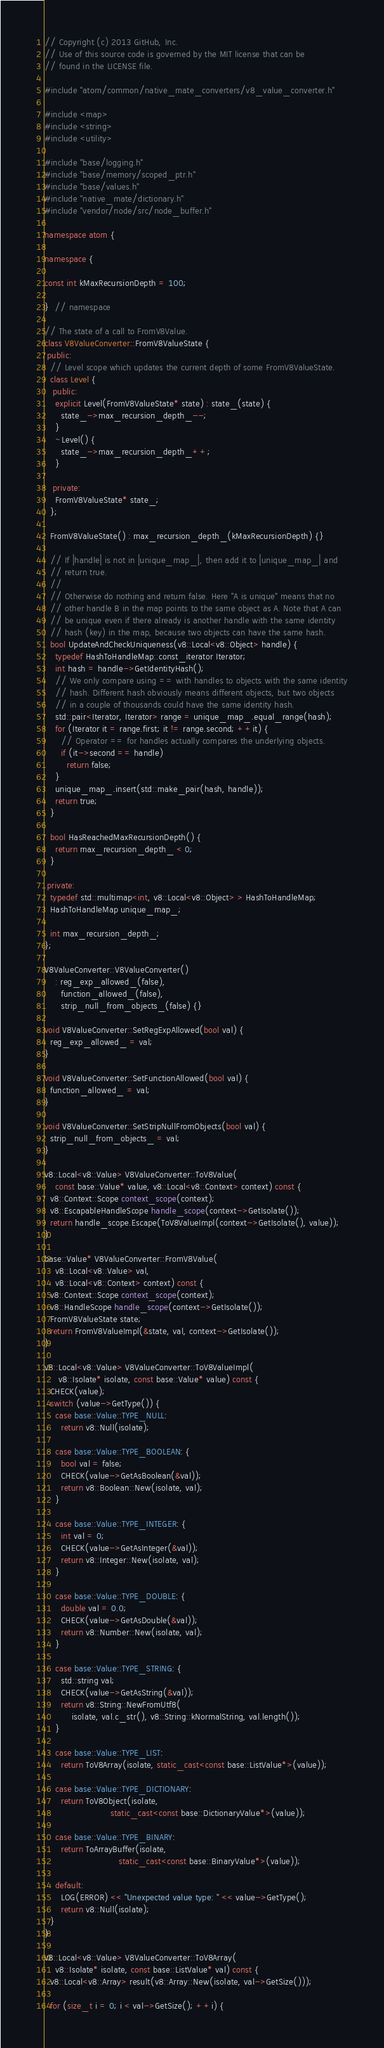<code> <loc_0><loc_0><loc_500><loc_500><_C++_>// Copyright (c) 2013 GitHub, Inc.
// Use of this source code is governed by the MIT license that can be
// found in the LICENSE file.

#include "atom/common/native_mate_converters/v8_value_converter.h"

#include <map>
#include <string>
#include <utility>

#include "base/logging.h"
#include "base/memory/scoped_ptr.h"
#include "base/values.h"
#include "native_mate/dictionary.h"
#include "vendor/node/src/node_buffer.h"

namespace atom {

namespace {

const int kMaxRecursionDepth = 100;

}  // namespace

// The state of a call to FromV8Value.
class V8ValueConverter::FromV8ValueState {
 public:
  // Level scope which updates the current depth of some FromV8ValueState.
  class Level {
   public:
    explicit Level(FromV8ValueState* state) : state_(state) {
      state_->max_recursion_depth_--;
    }
    ~Level() {
      state_->max_recursion_depth_++;
    }

   private:
    FromV8ValueState* state_;
  };

  FromV8ValueState() : max_recursion_depth_(kMaxRecursionDepth) {}

  // If |handle| is not in |unique_map_|, then add it to |unique_map_| and
  // return true.
  //
  // Otherwise do nothing and return false. Here "A is unique" means that no
  // other handle B in the map points to the same object as A. Note that A can
  // be unique even if there already is another handle with the same identity
  // hash (key) in the map, because two objects can have the same hash.
  bool UpdateAndCheckUniqueness(v8::Local<v8::Object> handle) {
    typedef HashToHandleMap::const_iterator Iterator;
    int hash = handle->GetIdentityHash();
    // We only compare using == with handles to objects with the same identity
    // hash. Different hash obviously means different objects, but two objects
    // in a couple of thousands could have the same identity hash.
    std::pair<Iterator, Iterator> range = unique_map_.equal_range(hash);
    for (Iterator it = range.first; it != range.second; ++it) {
      // Operator == for handles actually compares the underlying objects.
      if (it->second == handle)
        return false;
    }
    unique_map_.insert(std::make_pair(hash, handle));
    return true;
  }

  bool HasReachedMaxRecursionDepth() {
    return max_recursion_depth_ < 0;
  }

 private:
  typedef std::multimap<int, v8::Local<v8::Object> > HashToHandleMap;
  HashToHandleMap unique_map_;

  int max_recursion_depth_;
};

V8ValueConverter::V8ValueConverter()
    : reg_exp_allowed_(false),
      function_allowed_(false),
      strip_null_from_objects_(false) {}

void V8ValueConverter::SetRegExpAllowed(bool val) {
  reg_exp_allowed_ = val;
}

void V8ValueConverter::SetFunctionAllowed(bool val) {
  function_allowed_ = val;
}

void V8ValueConverter::SetStripNullFromObjects(bool val) {
  strip_null_from_objects_ = val;
}

v8::Local<v8::Value> V8ValueConverter::ToV8Value(
    const base::Value* value, v8::Local<v8::Context> context) const {
  v8::Context::Scope context_scope(context);
  v8::EscapableHandleScope handle_scope(context->GetIsolate());
  return handle_scope.Escape(ToV8ValueImpl(context->GetIsolate(), value));
}

base::Value* V8ValueConverter::FromV8Value(
    v8::Local<v8::Value> val,
    v8::Local<v8::Context> context) const {
  v8::Context::Scope context_scope(context);
  v8::HandleScope handle_scope(context->GetIsolate());
  FromV8ValueState state;
  return FromV8ValueImpl(&state, val, context->GetIsolate());
}

v8::Local<v8::Value> V8ValueConverter::ToV8ValueImpl(
     v8::Isolate* isolate, const base::Value* value) const {
  CHECK(value);
  switch (value->GetType()) {
    case base::Value::TYPE_NULL:
      return v8::Null(isolate);

    case base::Value::TYPE_BOOLEAN: {
      bool val = false;
      CHECK(value->GetAsBoolean(&val));
      return v8::Boolean::New(isolate, val);
    }

    case base::Value::TYPE_INTEGER: {
      int val = 0;
      CHECK(value->GetAsInteger(&val));
      return v8::Integer::New(isolate, val);
    }

    case base::Value::TYPE_DOUBLE: {
      double val = 0.0;
      CHECK(value->GetAsDouble(&val));
      return v8::Number::New(isolate, val);
    }

    case base::Value::TYPE_STRING: {
      std::string val;
      CHECK(value->GetAsString(&val));
      return v8::String::NewFromUtf8(
          isolate, val.c_str(), v8::String::kNormalString, val.length());
    }

    case base::Value::TYPE_LIST:
      return ToV8Array(isolate, static_cast<const base::ListValue*>(value));

    case base::Value::TYPE_DICTIONARY:
      return ToV8Object(isolate,
                        static_cast<const base::DictionaryValue*>(value));

    case base::Value::TYPE_BINARY:
      return ToArrayBuffer(isolate,
                           static_cast<const base::BinaryValue*>(value));

    default:
      LOG(ERROR) << "Unexpected value type: " << value->GetType();
      return v8::Null(isolate);
  }
}

v8::Local<v8::Value> V8ValueConverter::ToV8Array(
    v8::Isolate* isolate, const base::ListValue* val) const {
  v8::Local<v8::Array> result(v8::Array::New(isolate, val->GetSize()));

  for (size_t i = 0; i < val->GetSize(); ++i) {</code> 